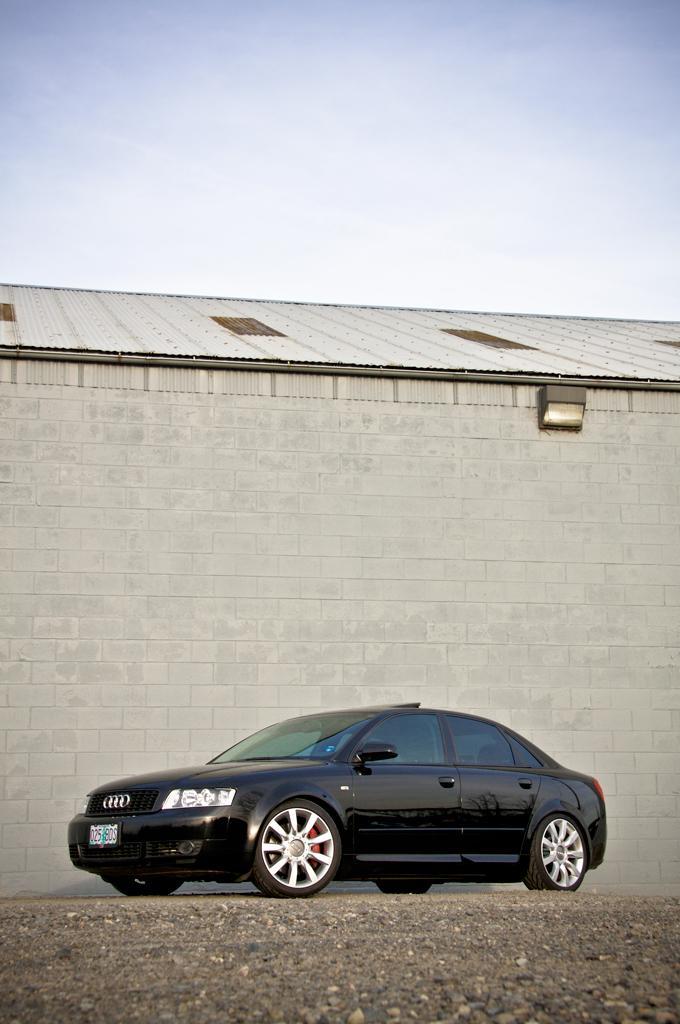Could you give a brief overview of what you see in this image? In this image there is a black car on the road. In the background there is a wall. At the top there is sky. 